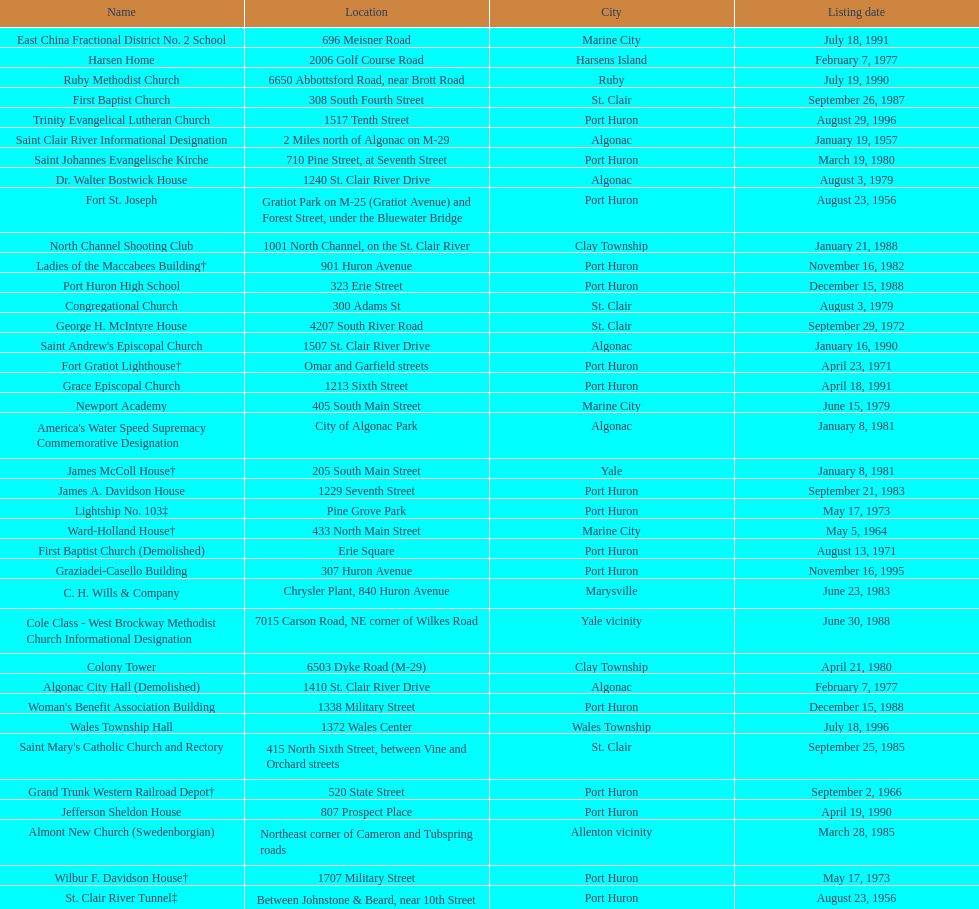How many names do not have images next to them? 41. 